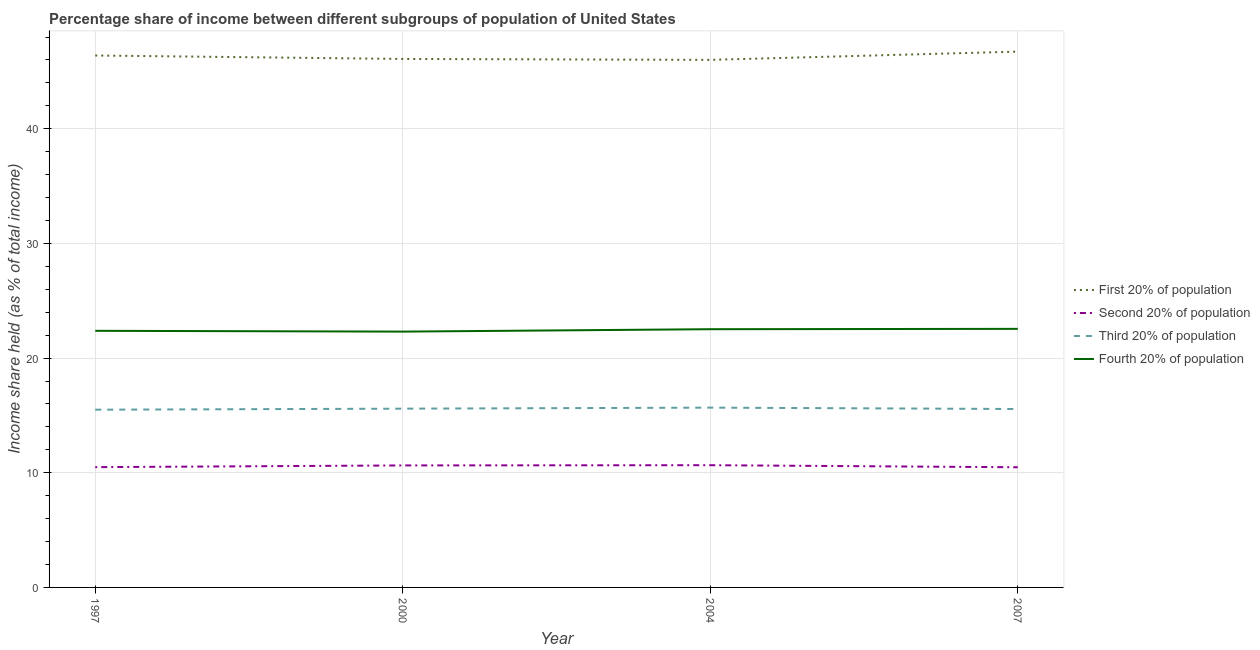How many different coloured lines are there?
Your response must be concise. 4. Does the line corresponding to share of the income held by second 20% of the population intersect with the line corresponding to share of the income held by first 20% of the population?
Keep it short and to the point. No. What is the share of the income held by second 20% of the population in 2007?
Your answer should be very brief. 10.48. Across all years, what is the maximum share of the income held by fourth 20% of the population?
Offer a very short reply. 22.55. In which year was the share of the income held by fourth 20% of the population maximum?
Your response must be concise. 2007. What is the total share of the income held by third 20% of the population in the graph?
Offer a terse response. 62.33. What is the difference between the share of the income held by fourth 20% of the population in 1997 and that in 2004?
Make the answer very short. -0.14. What is the average share of the income held by second 20% of the population per year?
Your answer should be very brief. 10.57. In the year 1997, what is the difference between the share of the income held by first 20% of the population and share of the income held by second 20% of the population?
Provide a succinct answer. 35.9. In how many years, is the share of the income held by first 20% of the population greater than 40 %?
Your response must be concise. 4. What is the ratio of the share of the income held by fourth 20% of the population in 1997 to that in 2000?
Keep it short and to the point. 1. What is the difference between the highest and the second highest share of the income held by second 20% of the population?
Your answer should be compact. 0.02. What is the difference between the highest and the lowest share of the income held by first 20% of the population?
Your answer should be compact. 0.72. In how many years, is the share of the income held by third 20% of the population greater than the average share of the income held by third 20% of the population taken over all years?
Provide a short and direct response. 2. Does the share of the income held by first 20% of the population monotonically increase over the years?
Ensure brevity in your answer.  No. Is the share of the income held by third 20% of the population strictly less than the share of the income held by fourth 20% of the population over the years?
Offer a terse response. Yes. How many lines are there?
Ensure brevity in your answer.  4. Does the graph contain grids?
Offer a terse response. Yes. How many legend labels are there?
Your response must be concise. 4. What is the title of the graph?
Offer a terse response. Percentage share of income between different subgroups of population of United States. Does "Debt policy" appear as one of the legend labels in the graph?
Keep it short and to the point. No. What is the label or title of the Y-axis?
Ensure brevity in your answer.  Income share held (as % of total income). What is the Income share held (as % of total income) in First 20% of population in 1997?
Keep it short and to the point. 46.39. What is the Income share held (as % of total income) in Second 20% of population in 1997?
Your response must be concise. 10.49. What is the Income share held (as % of total income) of Third 20% of population in 1997?
Offer a terse response. 15.5. What is the Income share held (as % of total income) in Fourth 20% of population in 1997?
Your response must be concise. 22.38. What is the Income share held (as % of total income) in First 20% of population in 2000?
Your response must be concise. 46.09. What is the Income share held (as % of total income) of Second 20% of population in 2000?
Provide a succinct answer. 10.64. What is the Income share held (as % of total income) in Third 20% of population in 2000?
Provide a succinct answer. 15.59. What is the Income share held (as % of total income) in Fourth 20% of population in 2000?
Ensure brevity in your answer.  22.31. What is the Income share held (as % of total income) in First 20% of population in 2004?
Ensure brevity in your answer.  46.01. What is the Income share held (as % of total income) of Second 20% of population in 2004?
Make the answer very short. 10.66. What is the Income share held (as % of total income) in Third 20% of population in 2004?
Make the answer very short. 15.68. What is the Income share held (as % of total income) in Fourth 20% of population in 2004?
Offer a terse response. 22.52. What is the Income share held (as % of total income) in First 20% of population in 2007?
Make the answer very short. 46.73. What is the Income share held (as % of total income) of Second 20% of population in 2007?
Your answer should be compact. 10.48. What is the Income share held (as % of total income) of Third 20% of population in 2007?
Your answer should be very brief. 15.56. What is the Income share held (as % of total income) of Fourth 20% of population in 2007?
Make the answer very short. 22.55. Across all years, what is the maximum Income share held (as % of total income) in First 20% of population?
Ensure brevity in your answer.  46.73. Across all years, what is the maximum Income share held (as % of total income) of Second 20% of population?
Offer a very short reply. 10.66. Across all years, what is the maximum Income share held (as % of total income) of Third 20% of population?
Your answer should be compact. 15.68. Across all years, what is the maximum Income share held (as % of total income) in Fourth 20% of population?
Your answer should be compact. 22.55. Across all years, what is the minimum Income share held (as % of total income) of First 20% of population?
Make the answer very short. 46.01. Across all years, what is the minimum Income share held (as % of total income) in Second 20% of population?
Keep it short and to the point. 10.48. Across all years, what is the minimum Income share held (as % of total income) in Third 20% of population?
Your response must be concise. 15.5. Across all years, what is the minimum Income share held (as % of total income) in Fourth 20% of population?
Give a very brief answer. 22.31. What is the total Income share held (as % of total income) in First 20% of population in the graph?
Offer a very short reply. 185.22. What is the total Income share held (as % of total income) of Second 20% of population in the graph?
Offer a very short reply. 42.27. What is the total Income share held (as % of total income) of Third 20% of population in the graph?
Provide a short and direct response. 62.33. What is the total Income share held (as % of total income) in Fourth 20% of population in the graph?
Your answer should be very brief. 89.76. What is the difference between the Income share held (as % of total income) in Second 20% of population in 1997 and that in 2000?
Provide a short and direct response. -0.15. What is the difference between the Income share held (as % of total income) in Third 20% of population in 1997 and that in 2000?
Offer a terse response. -0.09. What is the difference between the Income share held (as % of total income) in Fourth 20% of population in 1997 and that in 2000?
Ensure brevity in your answer.  0.07. What is the difference between the Income share held (as % of total income) in First 20% of population in 1997 and that in 2004?
Give a very brief answer. 0.38. What is the difference between the Income share held (as % of total income) in Second 20% of population in 1997 and that in 2004?
Keep it short and to the point. -0.17. What is the difference between the Income share held (as % of total income) in Third 20% of population in 1997 and that in 2004?
Your answer should be very brief. -0.18. What is the difference between the Income share held (as % of total income) of Fourth 20% of population in 1997 and that in 2004?
Provide a short and direct response. -0.14. What is the difference between the Income share held (as % of total income) of First 20% of population in 1997 and that in 2007?
Ensure brevity in your answer.  -0.34. What is the difference between the Income share held (as % of total income) of Second 20% of population in 1997 and that in 2007?
Offer a terse response. 0.01. What is the difference between the Income share held (as % of total income) of Third 20% of population in 1997 and that in 2007?
Keep it short and to the point. -0.06. What is the difference between the Income share held (as % of total income) of Fourth 20% of population in 1997 and that in 2007?
Offer a terse response. -0.17. What is the difference between the Income share held (as % of total income) in Second 20% of population in 2000 and that in 2004?
Provide a short and direct response. -0.02. What is the difference between the Income share held (as % of total income) of Third 20% of population in 2000 and that in 2004?
Make the answer very short. -0.09. What is the difference between the Income share held (as % of total income) in Fourth 20% of population in 2000 and that in 2004?
Offer a very short reply. -0.21. What is the difference between the Income share held (as % of total income) in First 20% of population in 2000 and that in 2007?
Offer a terse response. -0.64. What is the difference between the Income share held (as % of total income) in Second 20% of population in 2000 and that in 2007?
Your answer should be very brief. 0.16. What is the difference between the Income share held (as % of total income) in Fourth 20% of population in 2000 and that in 2007?
Make the answer very short. -0.24. What is the difference between the Income share held (as % of total income) in First 20% of population in 2004 and that in 2007?
Offer a very short reply. -0.72. What is the difference between the Income share held (as % of total income) in Second 20% of population in 2004 and that in 2007?
Give a very brief answer. 0.18. What is the difference between the Income share held (as % of total income) of Third 20% of population in 2004 and that in 2007?
Give a very brief answer. 0.12. What is the difference between the Income share held (as % of total income) of Fourth 20% of population in 2004 and that in 2007?
Provide a succinct answer. -0.03. What is the difference between the Income share held (as % of total income) in First 20% of population in 1997 and the Income share held (as % of total income) in Second 20% of population in 2000?
Offer a terse response. 35.75. What is the difference between the Income share held (as % of total income) in First 20% of population in 1997 and the Income share held (as % of total income) in Third 20% of population in 2000?
Give a very brief answer. 30.8. What is the difference between the Income share held (as % of total income) of First 20% of population in 1997 and the Income share held (as % of total income) of Fourth 20% of population in 2000?
Ensure brevity in your answer.  24.08. What is the difference between the Income share held (as % of total income) of Second 20% of population in 1997 and the Income share held (as % of total income) of Third 20% of population in 2000?
Your answer should be very brief. -5.1. What is the difference between the Income share held (as % of total income) of Second 20% of population in 1997 and the Income share held (as % of total income) of Fourth 20% of population in 2000?
Keep it short and to the point. -11.82. What is the difference between the Income share held (as % of total income) of Third 20% of population in 1997 and the Income share held (as % of total income) of Fourth 20% of population in 2000?
Make the answer very short. -6.81. What is the difference between the Income share held (as % of total income) in First 20% of population in 1997 and the Income share held (as % of total income) in Second 20% of population in 2004?
Your answer should be compact. 35.73. What is the difference between the Income share held (as % of total income) of First 20% of population in 1997 and the Income share held (as % of total income) of Third 20% of population in 2004?
Offer a very short reply. 30.71. What is the difference between the Income share held (as % of total income) in First 20% of population in 1997 and the Income share held (as % of total income) in Fourth 20% of population in 2004?
Give a very brief answer. 23.87. What is the difference between the Income share held (as % of total income) in Second 20% of population in 1997 and the Income share held (as % of total income) in Third 20% of population in 2004?
Make the answer very short. -5.19. What is the difference between the Income share held (as % of total income) in Second 20% of population in 1997 and the Income share held (as % of total income) in Fourth 20% of population in 2004?
Give a very brief answer. -12.03. What is the difference between the Income share held (as % of total income) of Third 20% of population in 1997 and the Income share held (as % of total income) of Fourth 20% of population in 2004?
Keep it short and to the point. -7.02. What is the difference between the Income share held (as % of total income) in First 20% of population in 1997 and the Income share held (as % of total income) in Second 20% of population in 2007?
Offer a very short reply. 35.91. What is the difference between the Income share held (as % of total income) in First 20% of population in 1997 and the Income share held (as % of total income) in Third 20% of population in 2007?
Make the answer very short. 30.83. What is the difference between the Income share held (as % of total income) of First 20% of population in 1997 and the Income share held (as % of total income) of Fourth 20% of population in 2007?
Offer a very short reply. 23.84. What is the difference between the Income share held (as % of total income) in Second 20% of population in 1997 and the Income share held (as % of total income) in Third 20% of population in 2007?
Offer a very short reply. -5.07. What is the difference between the Income share held (as % of total income) in Second 20% of population in 1997 and the Income share held (as % of total income) in Fourth 20% of population in 2007?
Ensure brevity in your answer.  -12.06. What is the difference between the Income share held (as % of total income) of Third 20% of population in 1997 and the Income share held (as % of total income) of Fourth 20% of population in 2007?
Provide a succinct answer. -7.05. What is the difference between the Income share held (as % of total income) in First 20% of population in 2000 and the Income share held (as % of total income) in Second 20% of population in 2004?
Offer a terse response. 35.43. What is the difference between the Income share held (as % of total income) of First 20% of population in 2000 and the Income share held (as % of total income) of Third 20% of population in 2004?
Give a very brief answer. 30.41. What is the difference between the Income share held (as % of total income) in First 20% of population in 2000 and the Income share held (as % of total income) in Fourth 20% of population in 2004?
Your answer should be compact. 23.57. What is the difference between the Income share held (as % of total income) in Second 20% of population in 2000 and the Income share held (as % of total income) in Third 20% of population in 2004?
Offer a terse response. -5.04. What is the difference between the Income share held (as % of total income) of Second 20% of population in 2000 and the Income share held (as % of total income) of Fourth 20% of population in 2004?
Your response must be concise. -11.88. What is the difference between the Income share held (as % of total income) of Third 20% of population in 2000 and the Income share held (as % of total income) of Fourth 20% of population in 2004?
Your answer should be very brief. -6.93. What is the difference between the Income share held (as % of total income) of First 20% of population in 2000 and the Income share held (as % of total income) of Second 20% of population in 2007?
Your answer should be very brief. 35.61. What is the difference between the Income share held (as % of total income) of First 20% of population in 2000 and the Income share held (as % of total income) of Third 20% of population in 2007?
Ensure brevity in your answer.  30.53. What is the difference between the Income share held (as % of total income) in First 20% of population in 2000 and the Income share held (as % of total income) in Fourth 20% of population in 2007?
Your response must be concise. 23.54. What is the difference between the Income share held (as % of total income) of Second 20% of population in 2000 and the Income share held (as % of total income) of Third 20% of population in 2007?
Your answer should be compact. -4.92. What is the difference between the Income share held (as % of total income) of Second 20% of population in 2000 and the Income share held (as % of total income) of Fourth 20% of population in 2007?
Ensure brevity in your answer.  -11.91. What is the difference between the Income share held (as % of total income) of Third 20% of population in 2000 and the Income share held (as % of total income) of Fourth 20% of population in 2007?
Keep it short and to the point. -6.96. What is the difference between the Income share held (as % of total income) of First 20% of population in 2004 and the Income share held (as % of total income) of Second 20% of population in 2007?
Give a very brief answer. 35.53. What is the difference between the Income share held (as % of total income) of First 20% of population in 2004 and the Income share held (as % of total income) of Third 20% of population in 2007?
Your answer should be very brief. 30.45. What is the difference between the Income share held (as % of total income) in First 20% of population in 2004 and the Income share held (as % of total income) in Fourth 20% of population in 2007?
Offer a very short reply. 23.46. What is the difference between the Income share held (as % of total income) of Second 20% of population in 2004 and the Income share held (as % of total income) of Third 20% of population in 2007?
Your response must be concise. -4.9. What is the difference between the Income share held (as % of total income) in Second 20% of population in 2004 and the Income share held (as % of total income) in Fourth 20% of population in 2007?
Your response must be concise. -11.89. What is the difference between the Income share held (as % of total income) of Third 20% of population in 2004 and the Income share held (as % of total income) of Fourth 20% of population in 2007?
Give a very brief answer. -6.87. What is the average Income share held (as % of total income) of First 20% of population per year?
Offer a terse response. 46.3. What is the average Income share held (as % of total income) of Second 20% of population per year?
Ensure brevity in your answer.  10.57. What is the average Income share held (as % of total income) of Third 20% of population per year?
Offer a very short reply. 15.58. What is the average Income share held (as % of total income) in Fourth 20% of population per year?
Offer a terse response. 22.44. In the year 1997, what is the difference between the Income share held (as % of total income) of First 20% of population and Income share held (as % of total income) of Second 20% of population?
Provide a short and direct response. 35.9. In the year 1997, what is the difference between the Income share held (as % of total income) in First 20% of population and Income share held (as % of total income) in Third 20% of population?
Offer a terse response. 30.89. In the year 1997, what is the difference between the Income share held (as % of total income) in First 20% of population and Income share held (as % of total income) in Fourth 20% of population?
Your response must be concise. 24.01. In the year 1997, what is the difference between the Income share held (as % of total income) of Second 20% of population and Income share held (as % of total income) of Third 20% of population?
Provide a succinct answer. -5.01. In the year 1997, what is the difference between the Income share held (as % of total income) of Second 20% of population and Income share held (as % of total income) of Fourth 20% of population?
Ensure brevity in your answer.  -11.89. In the year 1997, what is the difference between the Income share held (as % of total income) in Third 20% of population and Income share held (as % of total income) in Fourth 20% of population?
Offer a terse response. -6.88. In the year 2000, what is the difference between the Income share held (as % of total income) of First 20% of population and Income share held (as % of total income) of Second 20% of population?
Provide a short and direct response. 35.45. In the year 2000, what is the difference between the Income share held (as % of total income) in First 20% of population and Income share held (as % of total income) in Third 20% of population?
Provide a short and direct response. 30.5. In the year 2000, what is the difference between the Income share held (as % of total income) in First 20% of population and Income share held (as % of total income) in Fourth 20% of population?
Give a very brief answer. 23.78. In the year 2000, what is the difference between the Income share held (as % of total income) in Second 20% of population and Income share held (as % of total income) in Third 20% of population?
Make the answer very short. -4.95. In the year 2000, what is the difference between the Income share held (as % of total income) in Second 20% of population and Income share held (as % of total income) in Fourth 20% of population?
Ensure brevity in your answer.  -11.67. In the year 2000, what is the difference between the Income share held (as % of total income) in Third 20% of population and Income share held (as % of total income) in Fourth 20% of population?
Offer a terse response. -6.72. In the year 2004, what is the difference between the Income share held (as % of total income) of First 20% of population and Income share held (as % of total income) of Second 20% of population?
Offer a terse response. 35.35. In the year 2004, what is the difference between the Income share held (as % of total income) of First 20% of population and Income share held (as % of total income) of Third 20% of population?
Provide a short and direct response. 30.33. In the year 2004, what is the difference between the Income share held (as % of total income) of First 20% of population and Income share held (as % of total income) of Fourth 20% of population?
Offer a terse response. 23.49. In the year 2004, what is the difference between the Income share held (as % of total income) of Second 20% of population and Income share held (as % of total income) of Third 20% of population?
Give a very brief answer. -5.02. In the year 2004, what is the difference between the Income share held (as % of total income) in Second 20% of population and Income share held (as % of total income) in Fourth 20% of population?
Your answer should be compact. -11.86. In the year 2004, what is the difference between the Income share held (as % of total income) in Third 20% of population and Income share held (as % of total income) in Fourth 20% of population?
Provide a succinct answer. -6.84. In the year 2007, what is the difference between the Income share held (as % of total income) of First 20% of population and Income share held (as % of total income) of Second 20% of population?
Ensure brevity in your answer.  36.25. In the year 2007, what is the difference between the Income share held (as % of total income) of First 20% of population and Income share held (as % of total income) of Third 20% of population?
Offer a terse response. 31.17. In the year 2007, what is the difference between the Income share held (as % of total income) in First 20% of population and Income share held (as % of total income) in Fourth 20% of population?
Provide a succinct answer. 24.18. In the year 2007, what is the difference between the Income share held (as % of total income) in Second 20% of population and Income share held (as % of total income) in Third 20% of population?
Keep it short and to the point. -5.08. In the year 2007, what is the difference between the Income share held (as % of total income) in Second 20% of population and Income share held (as % of total income) in Fourth 20% of population?
Make the answer very short. -12.07. In the year 2007, what is the difference between the Income share held (as % of total income) of Third 20% of population and Income share held (as % of total income) of Fourth 20% of population?
Your answer should be very brief. -6.99. What is the ratio of the Income share held (as % of total income) of First 20% of population in 1997 to that in 2000?
Your answer should be very brief. 1.01. What is the ratio of the Income share held (as % of total income) of Second 20% of population in 1997 to that in 2000?
Keep it short and to the point. 0.99. What is the ratio of the Income share held (as % of total income) in First 20% of population in 1997 to that in 2004?
Your answer should be compact. 1.01. What is the ratio of the Income share held (as % of total income) in Second 20% of population in 1997 to that in 2004?
Offer a very short reply. 0.98. What is the ratio of the Income share held (as % of total income) in Third 20% of population in 1997 to that in 2004?
Ensure brevity in your answer.  0.99. What is the ratio of the Income share held (as % of total income) of Second 20% of population in 1997 to that in 2007?
Offer a terse response. 1. What is the ratio of the Income share held (as % of total income) in Fourth 20% of population in 1997 to that in 2007?
Provide a succinct answer. 0.99. What is the ratio of the Income share held (as % of total income) in Second 20% of population in 2000 to that in 2004?
Your response must be concise. 1. What is the ratio of the Income share held (as % of total income) in First 20% of population in 2000 to that in 2007?
Offer a terse response. 0.99. What is the ratio of the Income share held (as % of total income) of Second 20% of population in 2000 to that in 2007?
Provide a short and direct response. 1.02. What is the ratio of the Income share held (as % of total income) in Third 20% of population in 2000 to that in 2007?
Provide a succinct answer. 1. What is the ratio of the Income share held (as % of total income) in Fourth 20% of population in 2000 to that in 2007?
Your answer should be very brief. 0.99. What is the ratio of the Income share held (as % of total income) in First 20% of population in 2004 to that in 2007?
Ensure brevity in your answer.  0.98. What is the ratio of the Income share held (as % of total income) of Second 20% of population in 2004 to that in 2007?
Give a very brief answer. 1.02. What is the ratio of the Income share held (as % of total income) of Third 20% of population in 2004 to that in 2007?
Ensure brevity in your answer.  1.01. What is the ratio of the Income share held (as % of total income) in Fourth 20% of population in 2004 to that in 2007?
Provide a short and direct response. 1. What is the difference between the highest and the second highest Income share held (as % of total income) of First 20% of population?
Provide a short and direct response. 0.34. What is the difference between the highest and the second highest Income share held (as % of total income) in Third 20% of population?
Offer a terse response. 0.09. What is the difference between the highest and the lowest Income share held (as % of total income) of First 20% of population?
Provide a short and direct response. 0.72. What is the difference between the highest and the lowest Income share held (as % of total income) of Second 20% of population?
Your response must be concise. 0.18. What is the difference between the highest and the lowest Income share held (as % of total income) in Third 20% of population?
Your answer should be very brief. 0.18. What is the difference between the highest and the lowest Income share held (as % of total income) in Fourth 20% of population?
Keep it short and to the point. 0.24. 